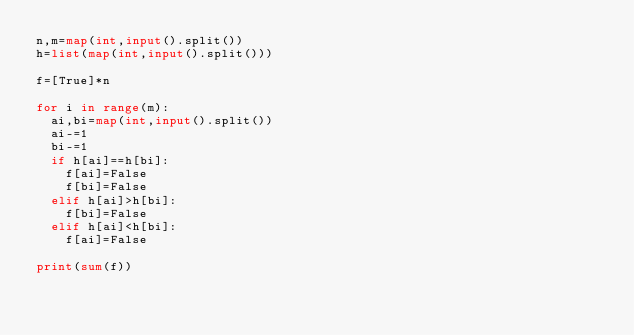<code> <loc_0><loc_0><loc_500><loc_500><_Python_>n,m=map(int,input().split())
h=list(map(int,input().split()))

f=[True]*n

for i in range(m):
  ai,bi=map(int,input().split())
  ai-=1
  bi-=1
  if h[ai]==h[bi]:
    f[ai]=False
    f[bi]=False
  elif h[ai]>h[bi]:
    f[bi]=False
  elif h[ai]<h[bi]:
    f[ai]=False

print(sum(f))
    </code> 